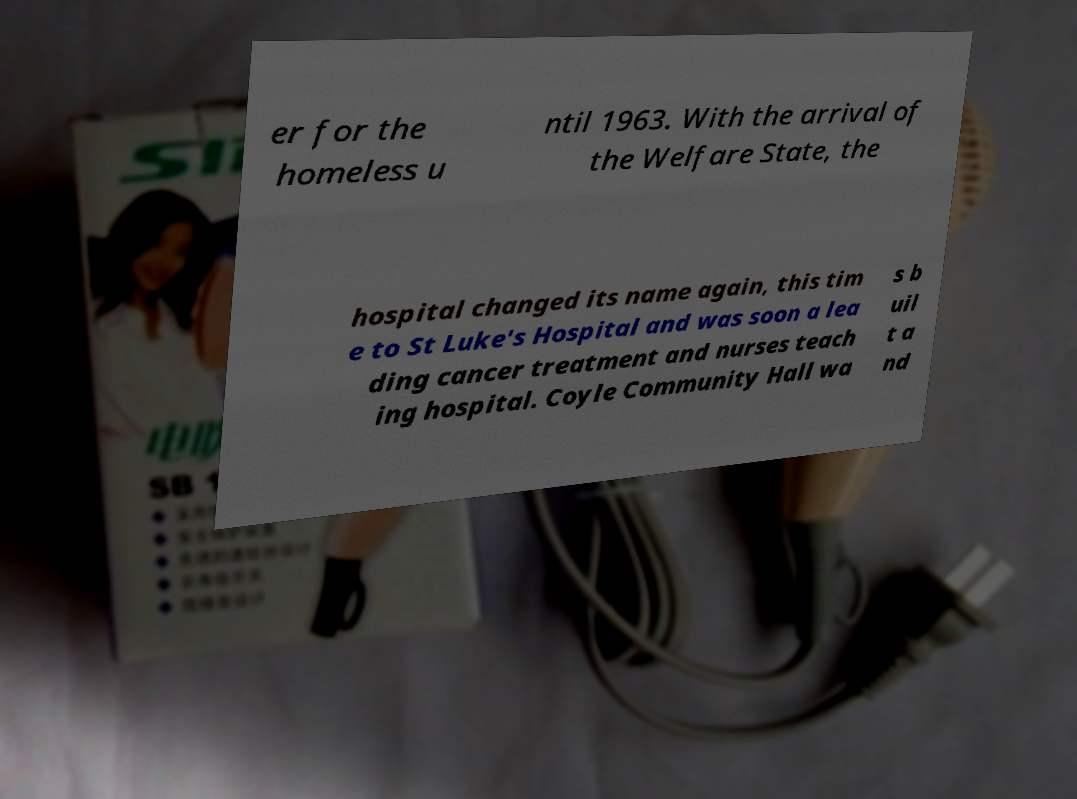Please identify and transcribe the text found in this image. er for the homeless u ntil 1963. With the arrival of the Welfare State, the hospital changed its name again, this tim e to St Luke's Hospital and was soon a lea ding cancer treatment and nurses teach ing hospital. Coyle Community Hall wa s b uil t a nd 